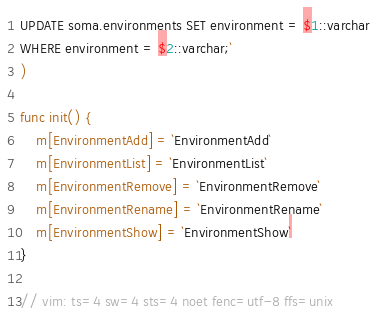Convert code to text. <code><loc_0><loc_0><loc_500><loc_500><_Go_>UPDATE soma.environments SET environment = $1::varchar
WHERE environment = $2::varchar;`
)

func init() {
	m[EnvironmentAdd] = `EnvironmentAdd`
	m[EnvironmentList] = `EnvironmentList`
	m[EnvironmentRemove] = `EnvironmentRemove`
	m[EnvironmentRename] = `EnvironmentRename`
	m[EnvironmentShow] = `EnvironmentShow`
}

// vim: ts=4 sw=4 sts=4 noet fenc=utf-8 ffs=unix
</code> 